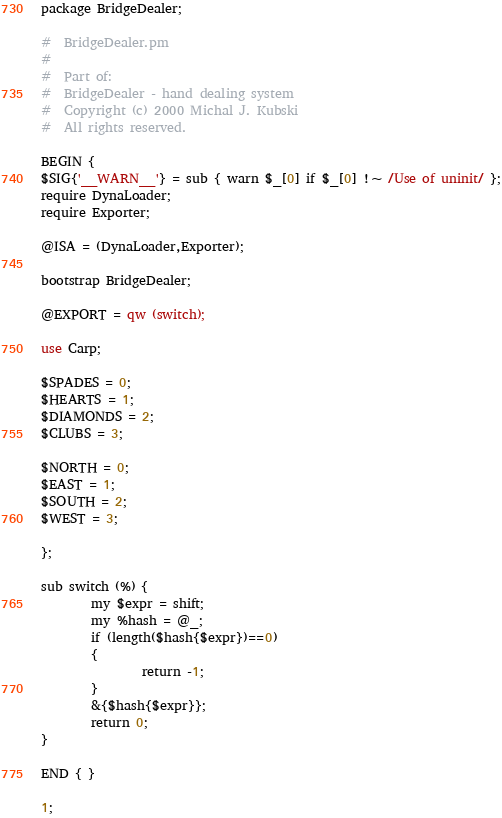Convert code to text. <code><loc_0><loc_0><loc_500><loc_500><_Perl_>package BridgeDealer;

#  BridgeDealer.pm
#
#  Part of:
#  BridgeDealer - hand dealing system
#  Copyright (c) 2000 Michal J. Kubski
#  All rights reserved.

BEGIN {
$SIG{'__WARN__'} = sub { warn $_[0] if $_[0] !~ /Use of uninit/ };
require DynaLoader;
require Exporter;

@ISA = (DynaLoader,Exporter);

bootstrap BridgeDealer;

@EXPORT = qw (switch);

use Carp;

$SPADES = 0;
$HEARTS = 1;
$DIAMONDS = 2;
$CLUBS = 3;

$NORTH = 0;
$EAST = 1;
$SOUTH = 2;
$WEST = 3;

};

sub switch (%) {
        my $expr = shift;
        my %hash = @_;
        if (length($hash{$expr})==0)
        {
                return -1;
        }
        &{$hash{$expr}};
        return 0;
}

END { }

1;</code> 